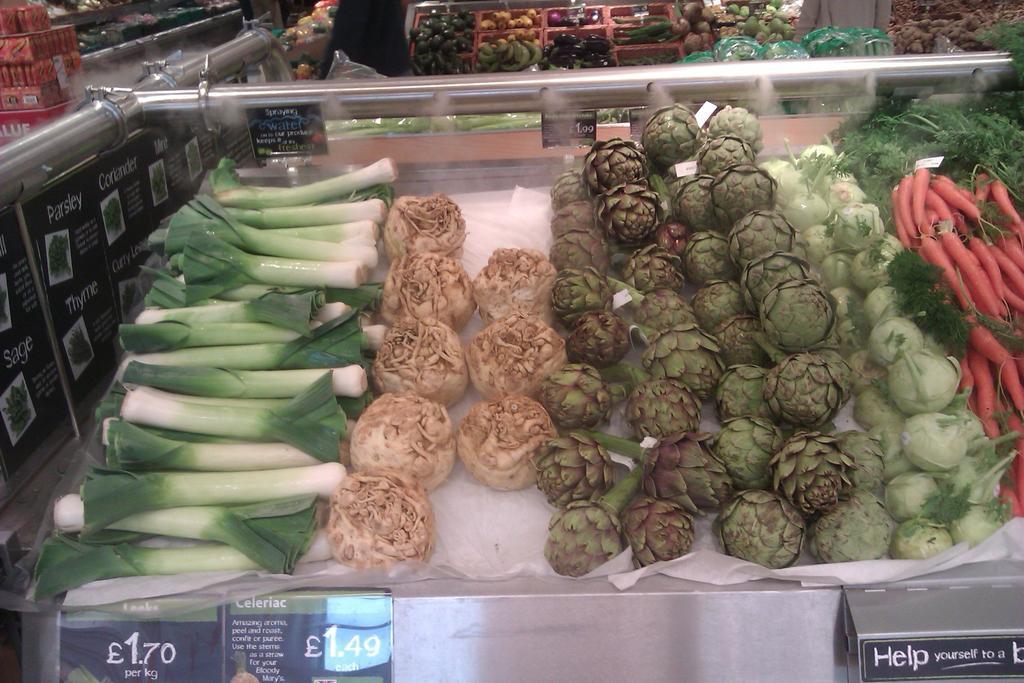Can you describe this image briefly? In this picture there are vegetables on the tables and in the baskets and there are boards on the table and there is text and there is price on the boards. 